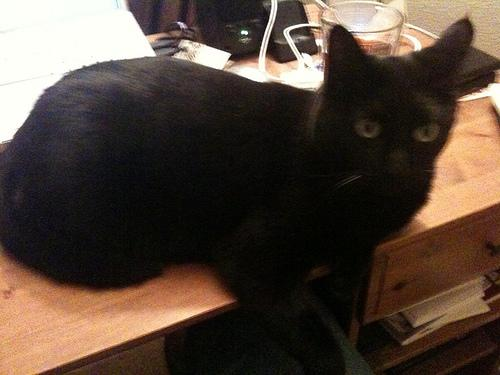What emotion does the cat appear to be expressing? surprise 